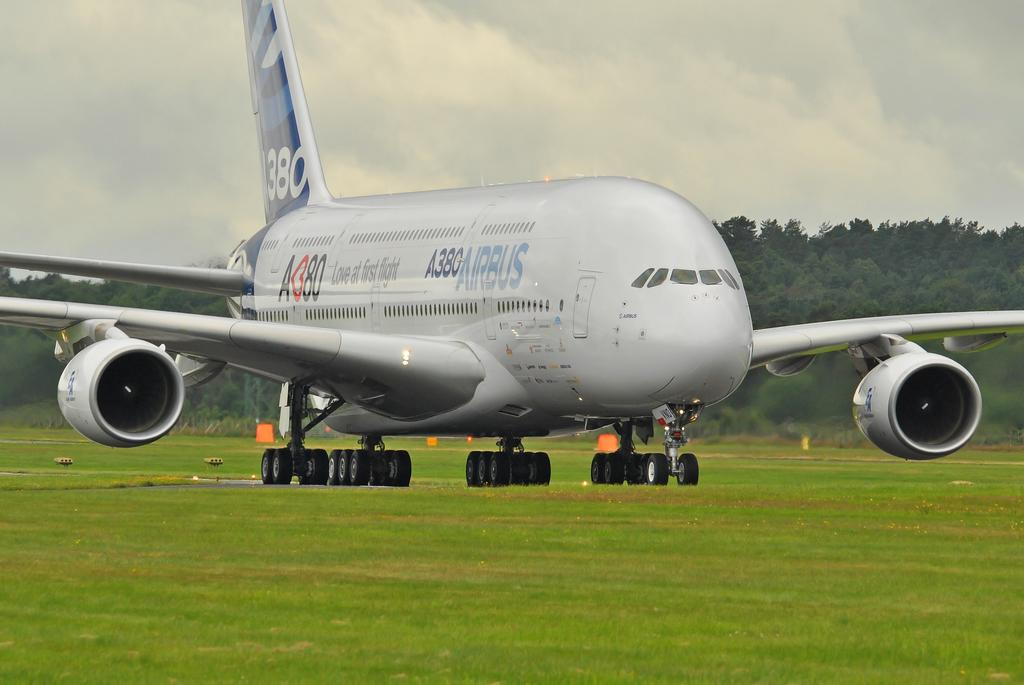<image>
Provide a brief description of the given image. An Airbus 380 passenger jet is on the ground in a grassy area. 